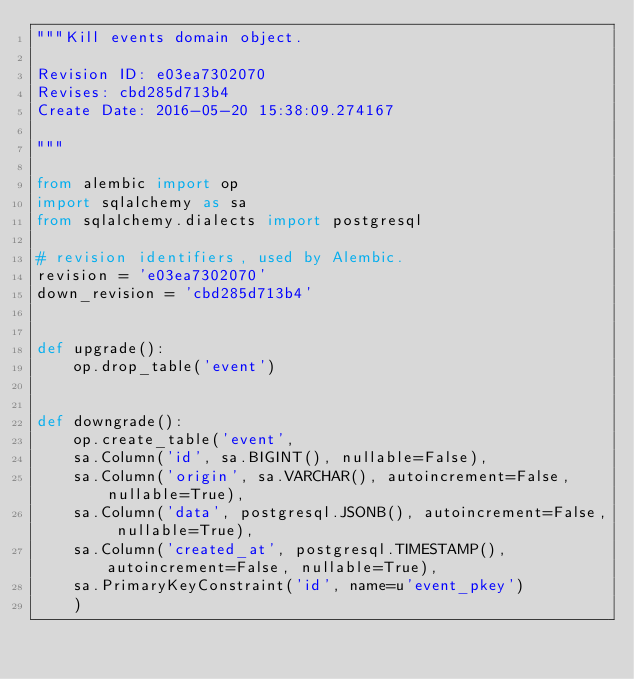<code> <loc_0><loc_0><loc_500><loc_500><_Python_>"""Kill events domain object.

Revision ID: e03ea7302070
Revises: cbd285d713b4
Create Date: 2016-05-20 15:38:09.274167

"""

from alembic import op
import sqlalchemy as sa
from sqlalchemy.dialects import postgresql

# revision identifiers, used by Alembic.
revision = 'e03ea7302070'
down_revision = 'cbd285d713b4'


def upgrade():
    op.drop_table('event')


def downgrade():
    op.create_table('event',
    sa.Column('id', sa.BIGINT(), nullable=False),
    sa.Column('origin', sa.VARCHAR(), autoincrement=False, nullable=True),
    sa.Column('data', postgresql.JSONB(), autoincrement=False, nullable=True),
    sa.Column('created_at', postgresql.TIMESTAMP(), autoincrement=False, nullable=True),
    sa.PrimaryKeyConstraint('id', name=u'event_pkey')
    )
</code> 